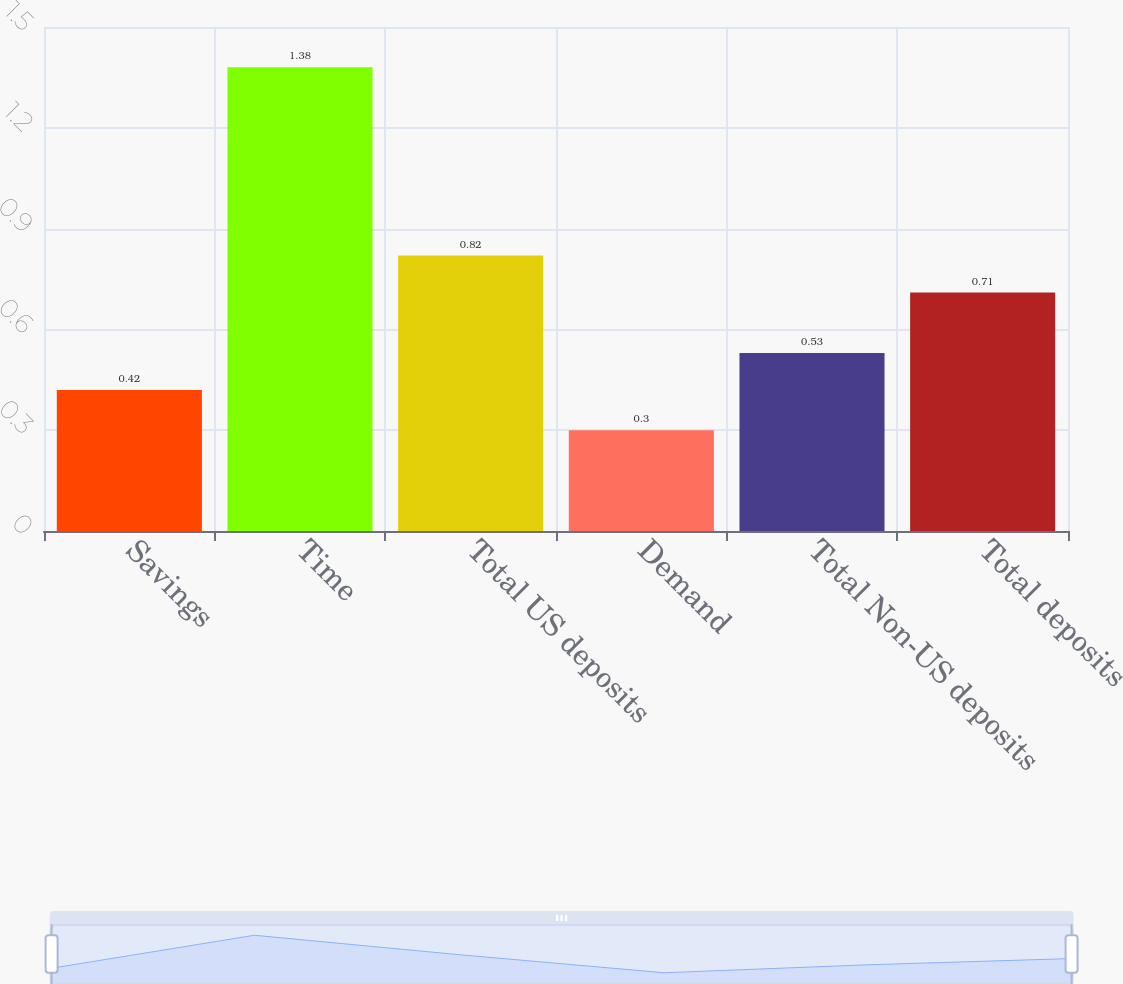<chart> <loc_0><loc_0><loc_500><loc_500><bar_chart><fcel>Savings<fcel>Time<fcel>Total US deposits<fcel>Demand<fcel>Total Non-US deposits<fcel>Total deposits<nl><fcel>0.42<fcel>1.38<fcel>0.82<fcel>0.3<fcel>0.53<fcel>0.71<nl></chart> 